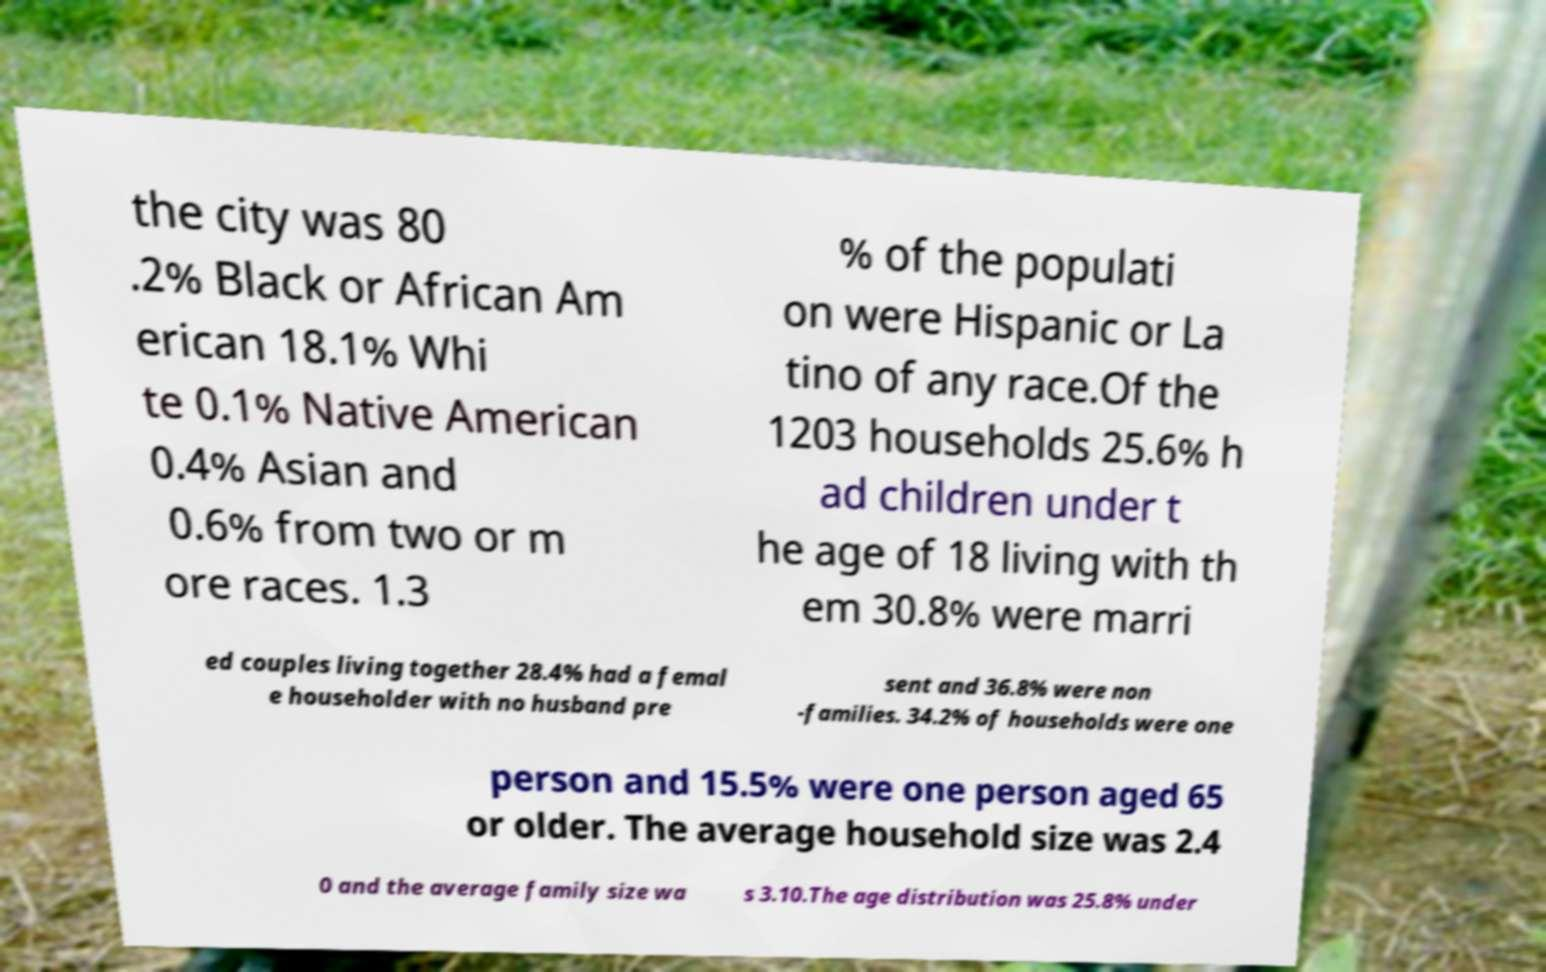Please read and relay the text visible in this image. What does it say? the city was 80 .2% Black or African Am erican 18.1% Whi te 0.1% Native American 0.4% Asian and 0.6% from two or m ore races. 1.3 % of the populati on were Hispanic or La tino of any race.Of the 1203 households 25.6% h ad children under t he age of 18 living with th em 30.8% were marri ed couples living together 28.4% had a femal e householder with no husband pre sent and 36.8% were non -families. 34.2% of households were one person and 15.5% were one person aged 65 or older. The average household size was 2.4 0 and the average family size wa s 3.10.The age distribution was 25.8% under 